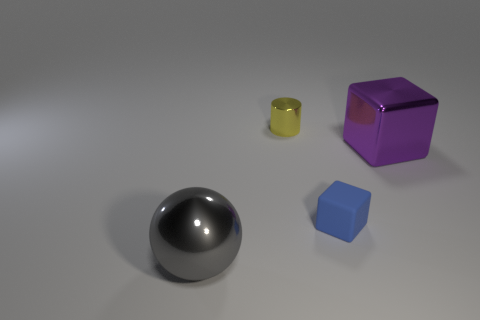Are there any other things that are the same material as the tiny cube?
Keep it short and to the point. No. Is the number of shiny objects that are to the right of the blue thing less than the number of tiny blue rubber cubes?
Offer a terse response. No. Is there a green matte cylinder of the same size as the blue cube?
Offer a very short reply. No. What is the color of the tiny shiny thing?
Your response must be concise. Yellow. Do the yellow cylinder and the purple metallic block have the same size?
Offer a very short reply. No. How many things are either tiny cyan spheres or cubes?
Give a very brief answer. 2. Is the number of tiny cylinders that are in front of the blue block the same as the number of big gray cubes?
Your response must be concise. Yes. There is a large metallic object that is on the left side of the big metal thing on the right side of the sphere; is there a gray sphere that is to the right of it?
Provide a succinct answer. No. There is a big block that is made of the same material as the gray sphere; what color is it?
Give a very brief answer. Purple. There is a shiny thing in front of the blue object; is its color the same as the big shiny block?
Make the answer very short. No. 